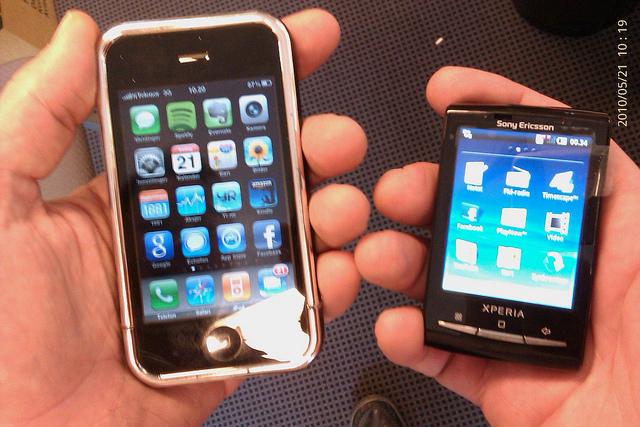Why is the man holding the phones?
Concise answer only. Comparing. Is this a smartphone?
Be succinct. Yes. Which phone is larger?
Write a very short answer. Left one. 